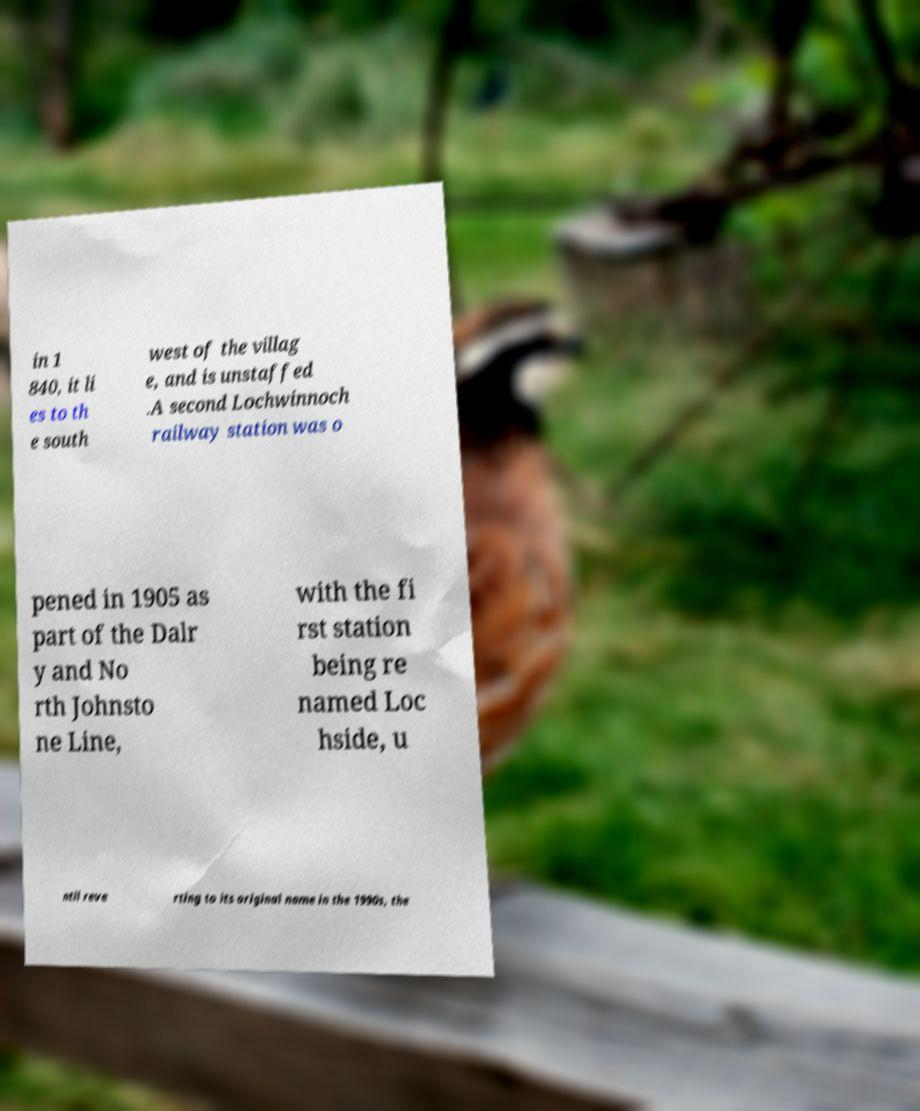What messages or text are displayed in this image? I need them in a readable, typed format. in 1 840, it li es to th e south west of the villag e, and is unstaffed .A second Lochwinnoch railway station was o pened in 1905 as part of the Dalr y and No rth Johnsto ne Line, with the fi rst station being re named Loc hside, u ntil reve rting to its original name in the 1990s, the 